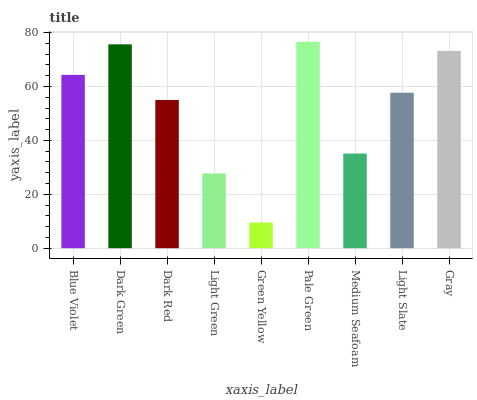Is Green Yellow the minimum?
Answer yes or no. Yes. Is Pale Green the maximum?
Answer yes or no. Yes. Is Dark Green the minimum?
Answer yes or no. No. Is Dark Green the maximum?
Answer yes or no. No. Is Dark Green greater than Blue Violet?
Answer yes or no. Yes. Is Blue Violet less than Dark Green?
Answer yes or no. Yes. Is Blue Violet greater than Dark Green?
Answer yes or no. No. Is Dark Green less than Blue Violet?
Answer yes or no. No. Is Light Slate the high median?
Answer yes or no. Yes. Is Light Slate the low median?
Answer yes or no. Yes. Is Light Green the high median?
Answer yes or no. No. Is Dark Green the low median?
Answer yes or no. No. 